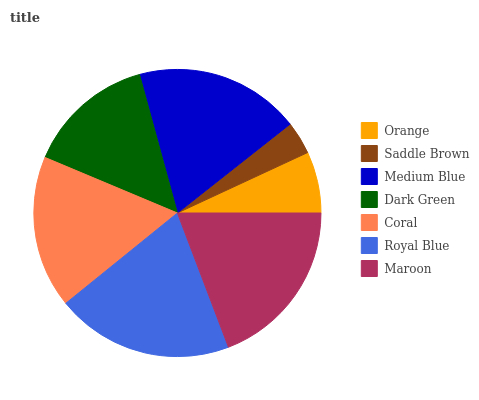Is Saddle Brown the minimum?
Answer yes or no. Yes. Is Royal Blue the maximum?
Answer yes or no. Yes. Is Medium Blue the minimum?
Answer yes or no. No. Is Medium Blue the maximum?
Answer yes or no. No. Is Medium Blue greater than Saddle Brown?
Answer yes or no. Yes. Is Saddle Brown less than Medium Blue?
Answer yes or no. Yes. Is Saddle Brown greater than Medium Blue?
Answer yes or no. No. Is Medium Blue less than Saddle Brown?
Answer yes or no. No. Is Coral the high median?
Answer yes or no. Yes. Is Coral the low median?
Answer yes or no. Yes. Is Saddle Brown the high median?
Answer yes or no. No. Is Medium Blue the low median?
Answer yes or no. No. 